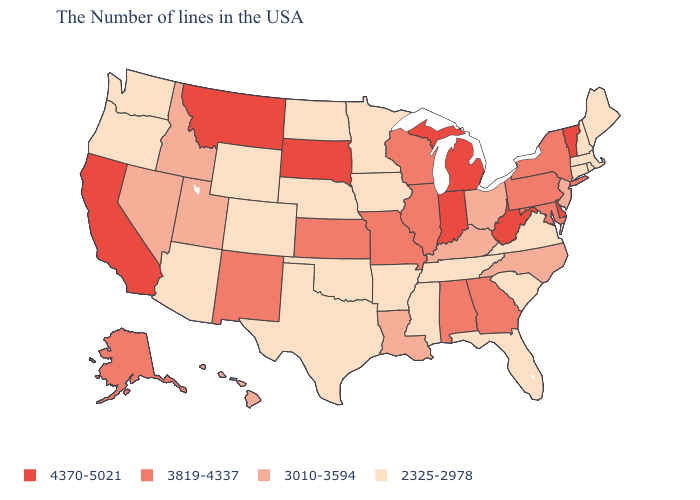Name the states that have a value in the range 3010-3594?
Answer briefly. New Jersey, North Carolina, Ohio, Kentucky, Louisiana, Utah, Idaho, Nevada, Hawaii. What is the highest value in the USA?
Be succinct. 4370-5021. Among the states that border South Carolina , does Georgia have the highest value?
Quick response, please. Yes. Does Rhode Island have a lower value than Wyoming?
Keep it brief. No. What is the highest value in the USA?
Answer briefly. 4370-5021. Among the states that border Massachusetts , does Connecticut have the lowest value?
Short answer required. Yes. Does Wyoming have the lowest value in the USA?
Short answer required. Yes. Does Iowa have a higher value than Hawaii?
Quick response, please. No. What is the highest value in the USA?
Answer briefly. 4370-5021. Is the legend a continuous bar?
Be succinct. No. What is the value of South Dakota?
Quick response, please. 4370-5021. Name the states that have a value in the range 3819-4337?
Give a very brief answer. New York, Maryland, Pennsylvania, Georgia, Alabama, Wisconsin, Illinois, Missouri, Kansas, New Mexico, Alaska. What is the value of Arizona?
Write a very short answer. 2325-2978. Does Connecticut have a higher value than Alaska?
Quick response, please. No. What is the highest value in the USA?
Short answer required. 4370-5021. 